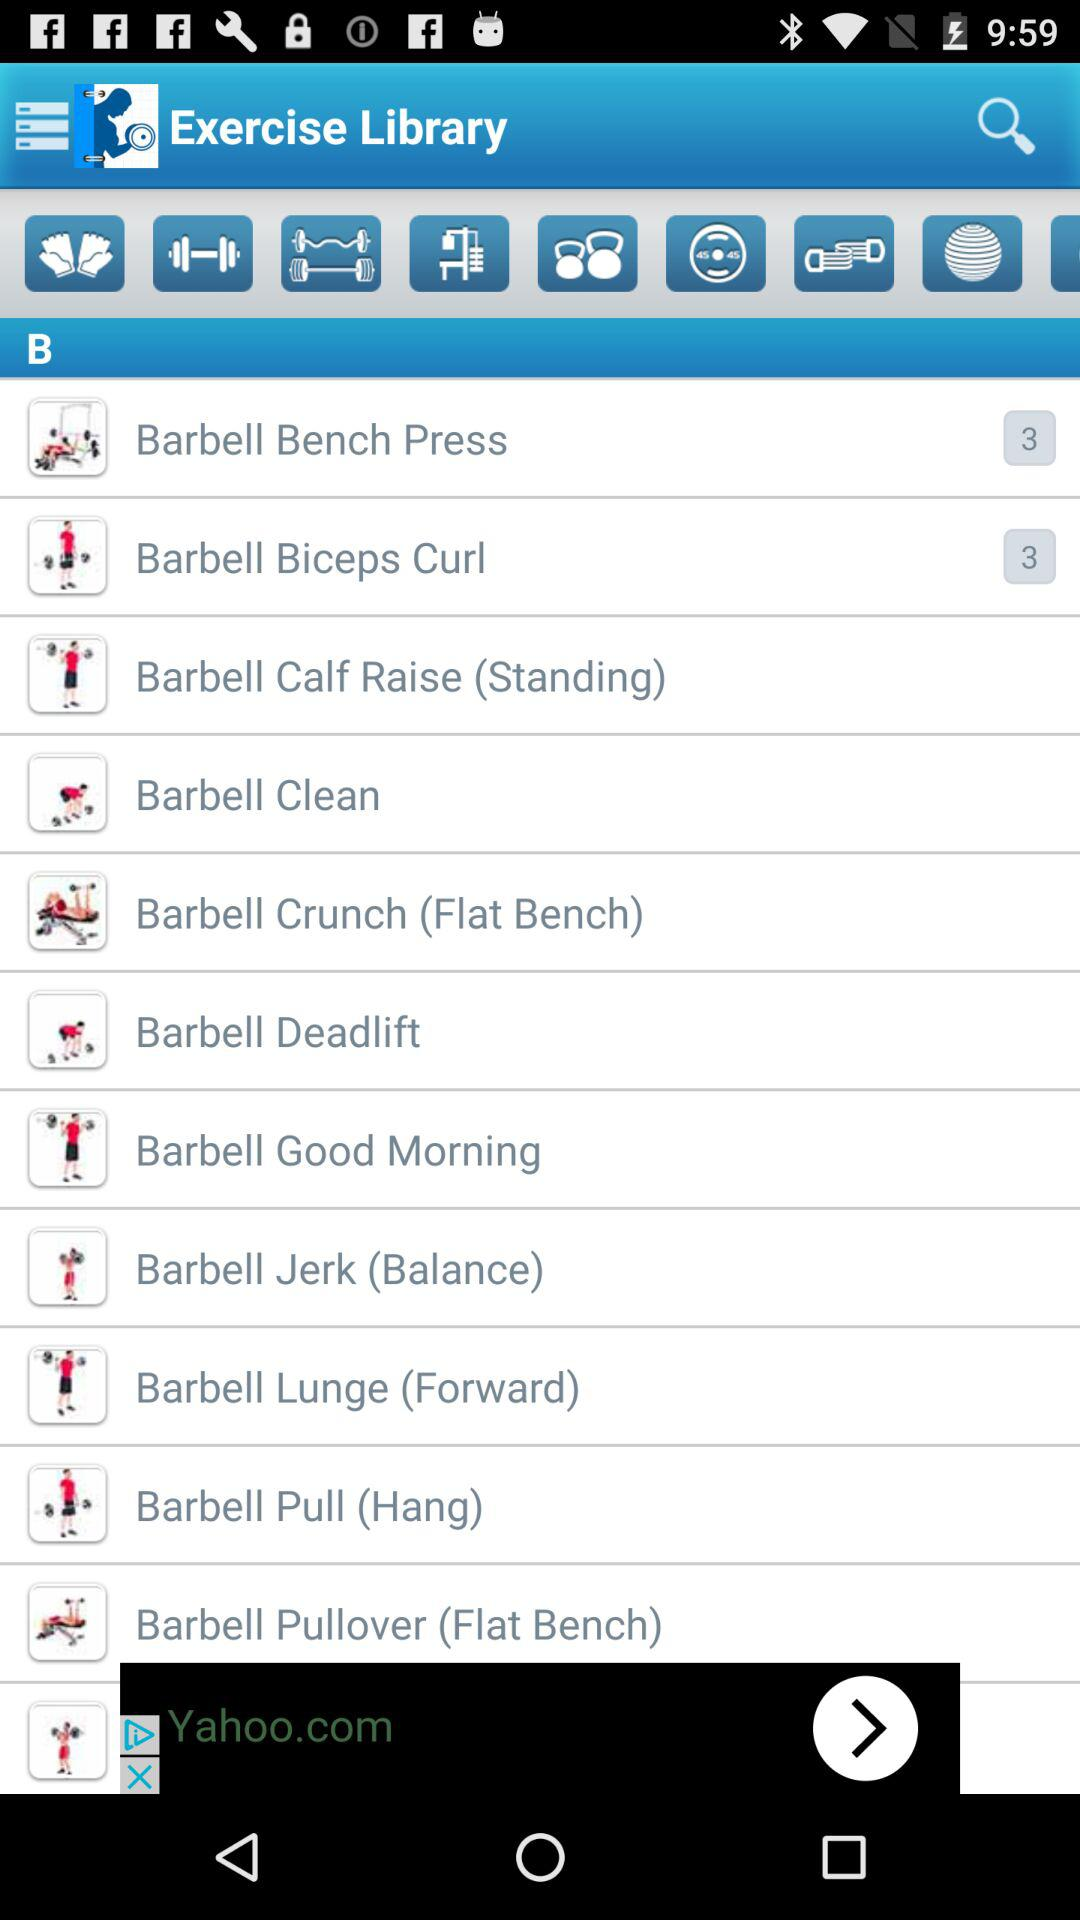How many items are in "Barbell Crunch (Flat Bench)"?
When the provided information is insufficient, respond with <no answer>. <no answer> 